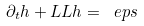<formula> <loc_0><loc_0><loc_500><loc_500>\partial _ { t } h + \L L L h = \ e p s</formula> 